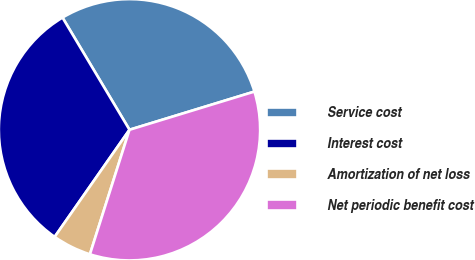Convert chart to OTSL. <chart><loc_0><loc_0><loc_500><loc_500><pie_chart><fcel>Service cost<fcel>Interest cost<fcel>Amortization of net loss<fcel>Net periodic benefit cost<nl><fcel>28.85%<fcel>31.73%<fcel>4.81%<fcel>34.62%<nl></chart> 